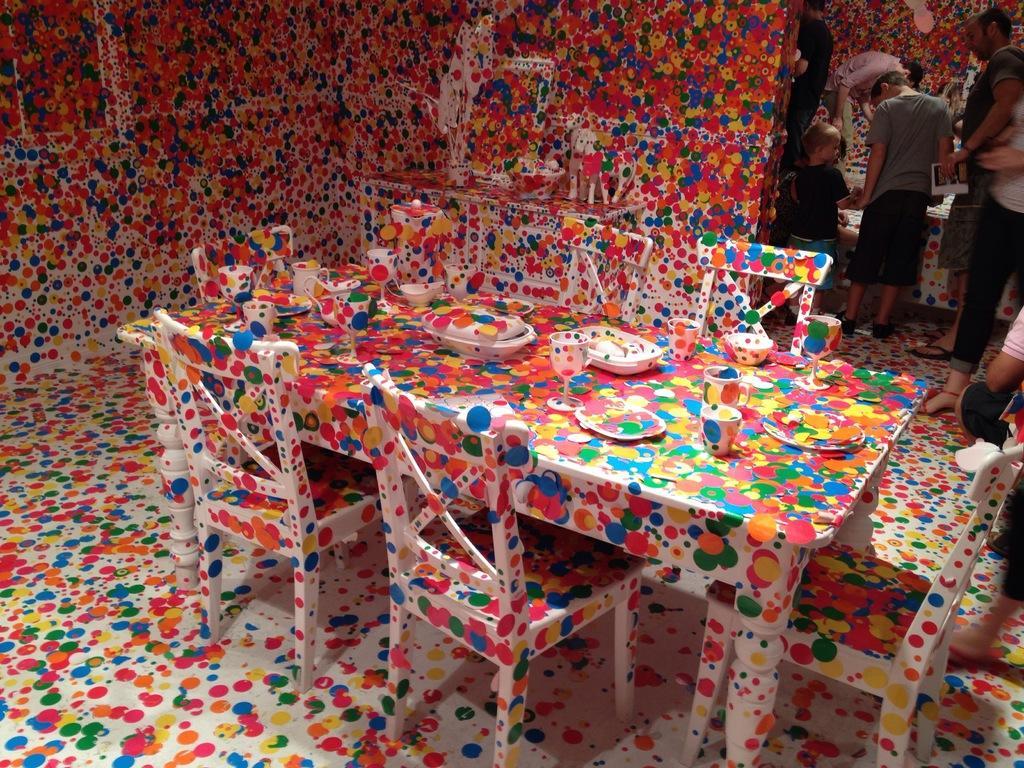In one or two sentences, can you explain what this image depicts? This picture is taken inside the room. In this image, on the right side, we can see a group of people are standing. In the middle of the image, we can see some tables and chairs. On the table, we can see some cups, plates, bowl. On the left side, we can see a window with some colors. 